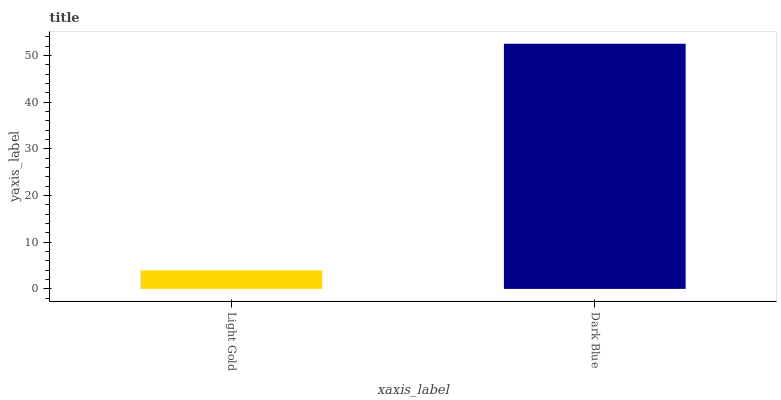Is Light Gold the minimum?
Answer yes or no. Yes. Is Dark Blue the maximum?
Answer yes or no. Yes. Is Dark Blue the minimum?
Answer yes or no. No. Is Dark Blue greater than Light Gold?
Answer yes or no. Yes. Is Light Gold less than Dark Blue?
Answer yes or no. Yes. Is Light Gold greater than Dark Blue?
Answer yes or no. No. Is Dark Blue less than Light Gold?
Answer yes or no. No. Is Dark Blue the high median?
Answer yes or no. Yes. Is Light Gold the low median?
Answer yes or no. Yes. Is Light Gold the high median?
Answer yes or no. No. Is Dark Blue the low median?
Answer yes or no. No. 